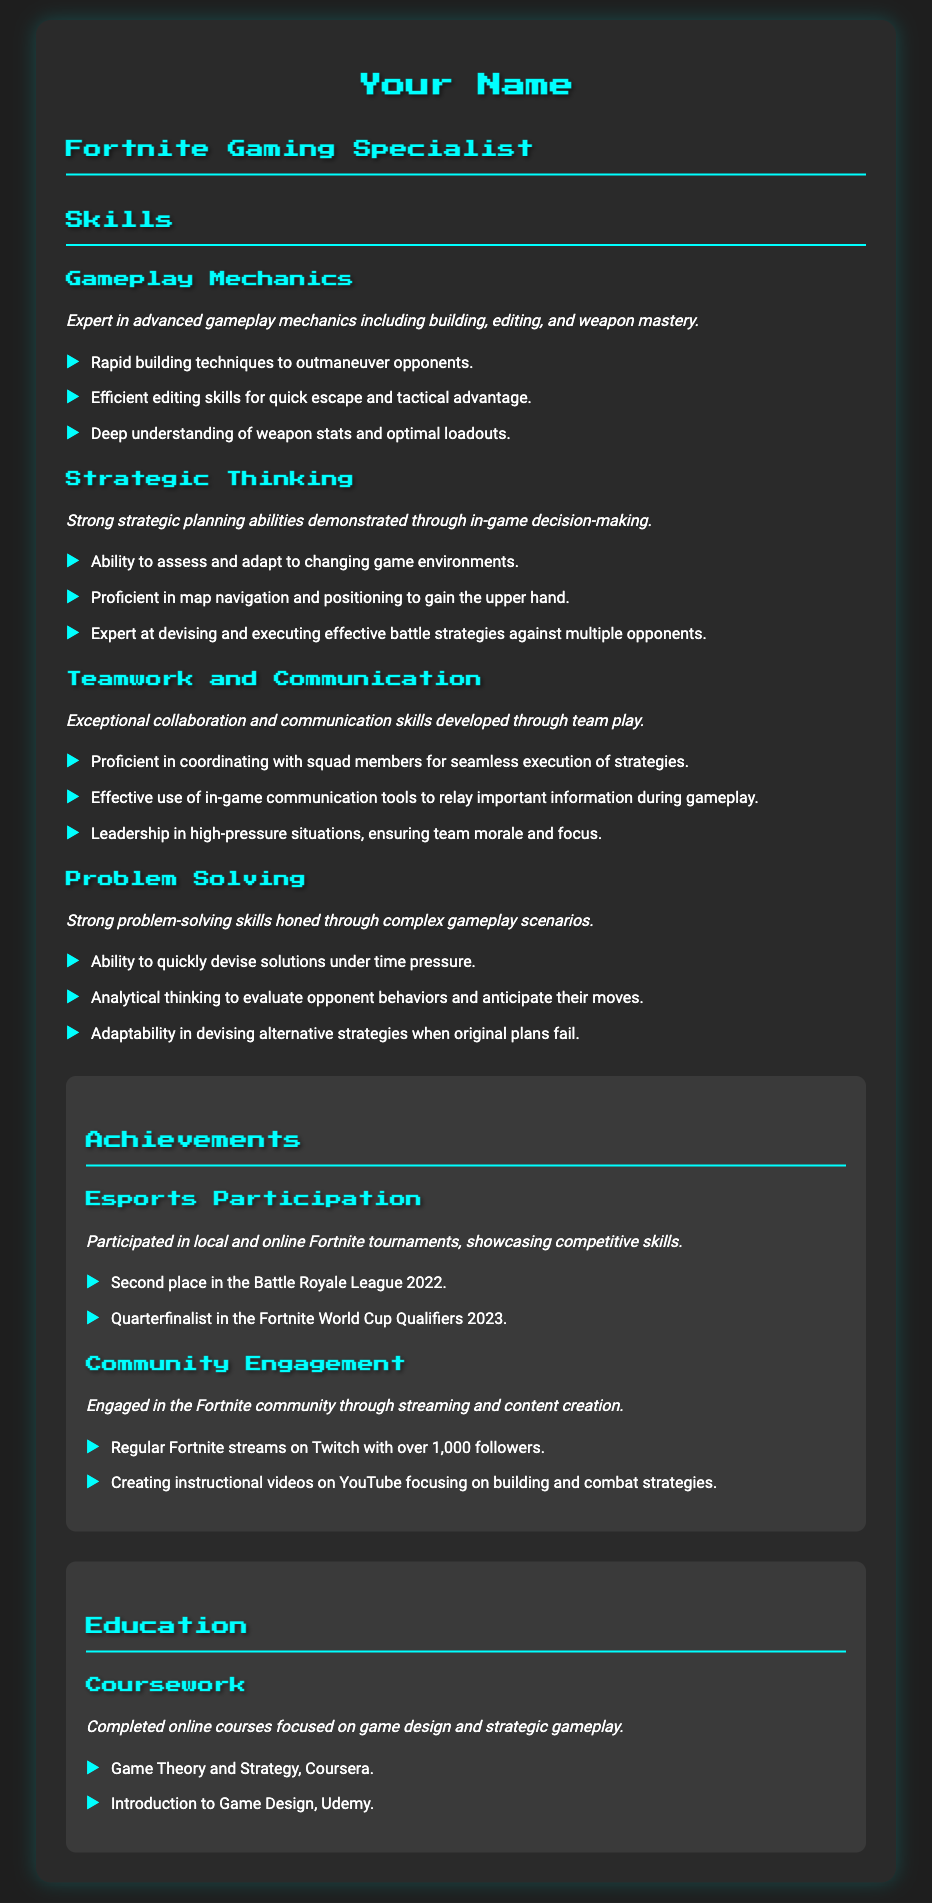What is the person's title? The title of the person is listed directly under their name, indicating their expertise in gaming.
Answer: Fortnite Gaming Specialist Which skill involves quick escape and tactical advantage? The skill listed under "Gameplay Mechanics" that emphasizes this ability is stated in the document.
Answer: Editing skills What place did they achieve in the Battle Royale League 2022? This information is included under the "Achievements" section related to esports participation.
Answer: Second place How many Twitch followers does the person have? The number of followers is mentioned in the Community Engagement section that highlights their streaming activities.
Answer: Over 1,000 followers What type of courses did the person complete? The types of courses completed are listed under the "Education" section that details their online learning activities.
Answer: Game design and strategic gameplay What skill is emphasized by the ability to adapt to changing game environments? This refers to the strategic skill that focuses on planning and decision-making during gameplay.
Answer: Strategic Thinking What tournament did the person reach the quarterfinals in? This specific tournament is mentioned in relation to their esports achievements.
Answer: Fortnite World Cup Qualifiers 2023 What platform does the person use for streaming? The platform used for streaming is detailed in the Community Engagement section as part of their gaming activities.
Answer: Twitch Which course was taken on Coursera? This course is listed in the Education section, specifying where the coursework was completed.
Answer: Game Theory and Strategy 